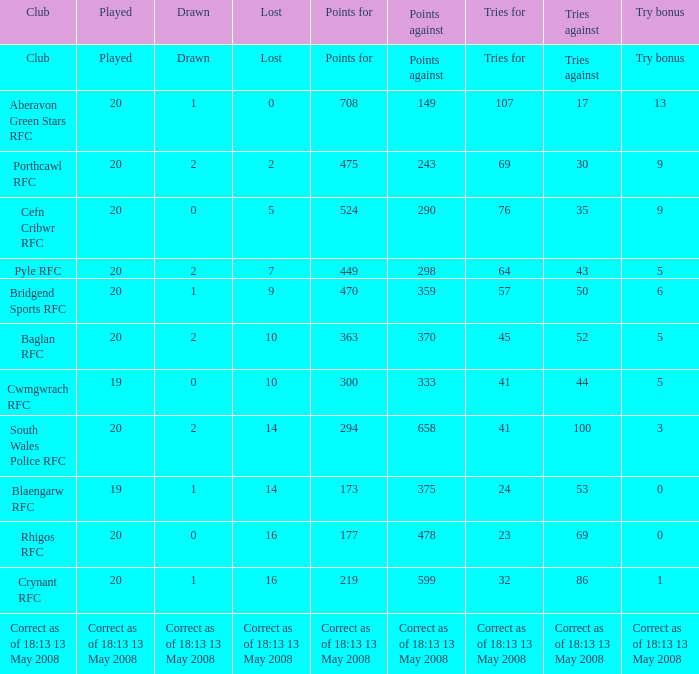What is the points number when 20 shows for played, and lost is 0? 708.0. Can you give me this table as a dict? {'header': ['Club', 'Played', 'Drawn', 'Lost', 'Points for', 'Points against', 'Tries for', 'Tries against', 'Try bonus'], 'rows': [['Club', 'Played', 'Drawn', 'Lost', 'Points for', 'Points against', 'Tries for', 'Tries against', 'Try bonus'], ['Aberavon Green Stars RFC', '20', '1', '0', '708', '149', '107', '17', '13'], ['Porthcawl RFC', '20', '2', '2', '475', '243', '69', '30', '9'], ['Cefn Cribwr RFC', '20', '0', '5', '524', '290', '76', '35', '9'], ['Pyle RFC', '20', '2', '7', '449', '298', '64', '43', '5'], ['Bridgend Sports RFC', '20', '1', '9', '470', '359', '57', '50', '6'], ['Baglan RFC', '20', '2', '10', '363', '370', '45', '52', '5'], ['Cwmgwrach RFC', '19', '0', '10', '300', '333', '41', '44', '5'], ['South Wales Police RFC', '20', '2', '14', '294', '658', '41', '100', '3'], ['Blaengarw RFC', '19', '1', '14', '173', '375', '24', '53', '0'], ['Rhigos RFC', '20', '0', '16', '177', '478', '23', '69', '0'], ['Crynant RFC', '20', '1', '16', '219', '599', '32', '86', '1'], ['Correct as of 18:13 13 May 2008', 'Correct as of 18:13 13 May 2008', 'Correct as of 18:13 13 May 2008', 'Correct as of 18:13 13 May 2008', 'Correct as of 18:13 13 May 2008', 'Correct as of 18:13 13 May 2008', 'Correct as of 18:13 13 May 2008', 'Correct as of 18:13 13 May 2008', 'Correct as of 18:13 13 May 2008']]} 